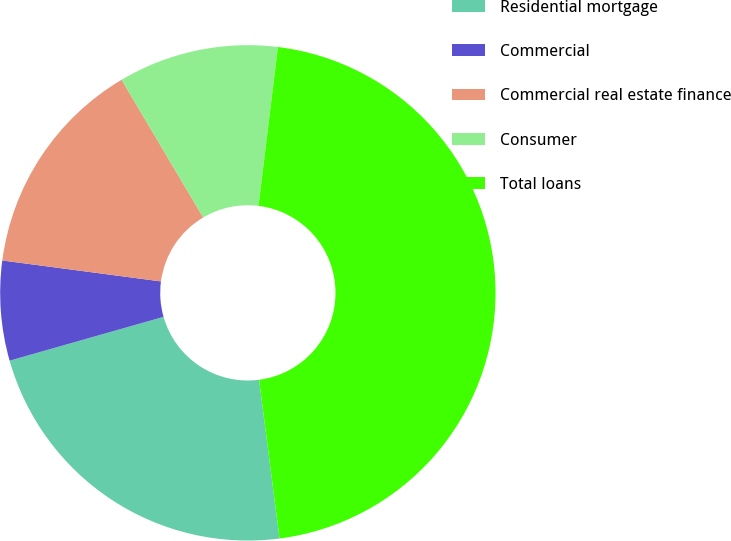Convert chart to OTSL. <chart><loc_0><loc_0><loc_500><loc_500><pie_chart><fcel>Residential mortgage<fcel>Commercial<fcel>Commercial real estate finance<fcel>Consumer<fcel>Total loans<nl><fcel>22.63%<fcel>6.5%<fcel>14.4%<fcel>10.45%<fcel>46.02%<nl></chart> 